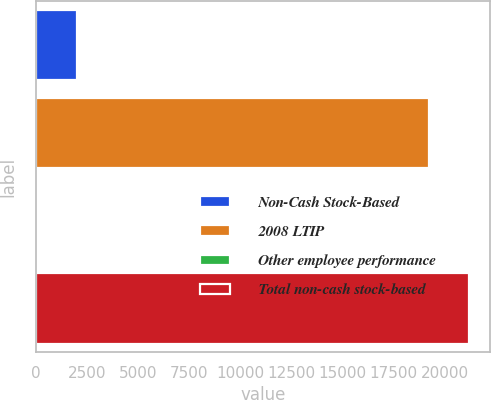<chart> <loc_0><loc_0><loc_500><loc_500><bar_chart><fcel>Non-Cash Stock-Based<fcel>2008 LTIP<fcel>Other employee performance<fcel>Total non-cash stock-based<nl><fcel>2011<fcel>19230<fcel>10<fcel>21153<nl></chart> 